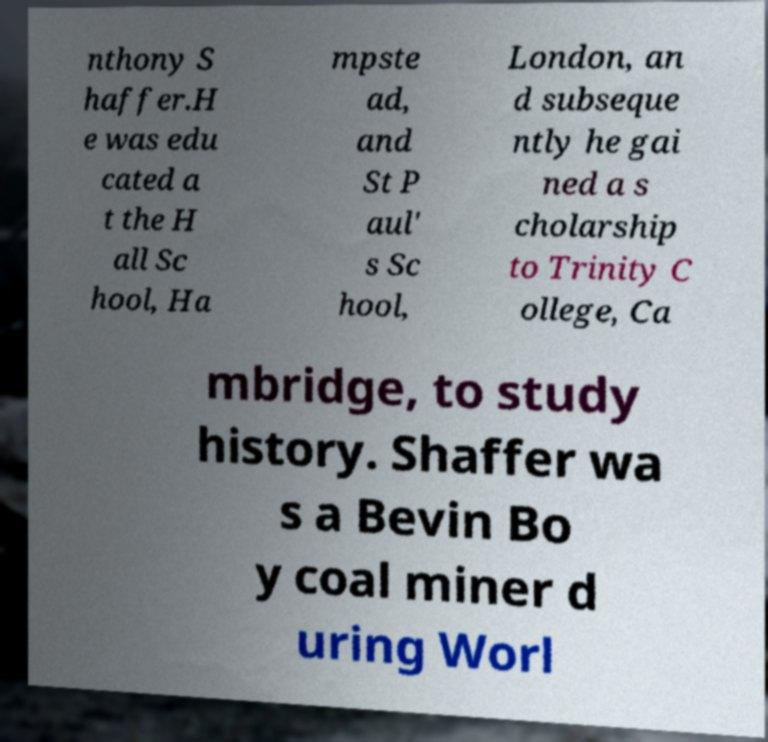Please read and relay the text visible in this image. What does it say? nthony S haffer.H e was edu cated a t the H all Sc hool, Ha mpste ad, and St P aul' s Sc hool, London, an d subseque ntly he gai ned a s cholarship to Trinity C ollege, Ca mbridge, to study history. Shaffer wa s a Bevin Bo y coal miner d uring Worl 